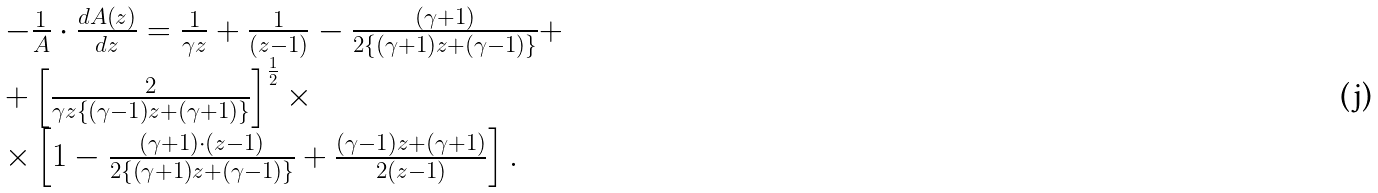Convert formula to latex. <formula><loc_0><loc_0><loc_500><loc_500>\begin{array} { l } - \frac { 1 } { A } \cdot \frac { { d A \left ( { z } \right ) } } { d z } = \frac { 1 } { \gamma z } + \frac { 1 } { { \left ( { z - 1 } \right ) } } - \frac { { \left ( { \gamma + 1 } \right ) } } { { 2 \left \{ { \left ( { \gamma + 1 } \right ) z + \left ( { \gamma - 1 } \right ) } \right \} } } + \\ + \left [ { \frac { 2 } { { \gamma z \left \{ { \left ( { \gamma - 1 } \right ) z + \left ( { \gamma + 1 } \right ) } \right \} } } } \right ] ^ { \frac { 1 } { 2 } } \times \\ \times \left [ { 1 - \frac { { \left ( { \gamma + 1 } \right ) \cdot \left ( { z - 1 } \right ) } } { { 2 \left \{ { \left ( { \gamma + 1 } \right ) z + \left ( { \gamma - 1 } \right ) } \right \} } } + \frac { { \left ( { \gamma - 1 } \right ) z + \left ( { \gamma + 1 } \right ) } } { { 2 \left ( { z - 1 } \right ) } } } \right ] . \\ \end{array}</formula> 